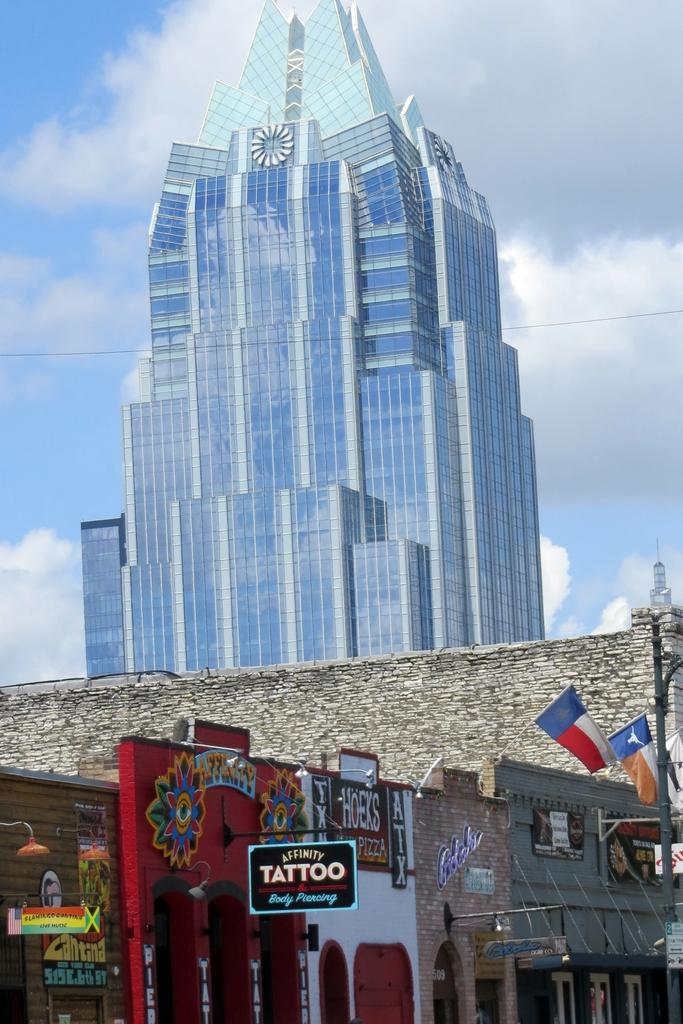What type of structures are present in the image? There are stalls in the image. What decorative elements can be seen in the image? There are flags in the image. What provides illumination in the image? There are light poles in the image. What type of building is visible in the background of the image? There is a glass building in the background of the image. What is the color of the sky in the image? The sky is blue and white in color. Can you see any boats in the image? There are no boats present in the image. Is there a stranger interacting with the stalls in the image? There is no stranger interacting with the stalls in the image. 